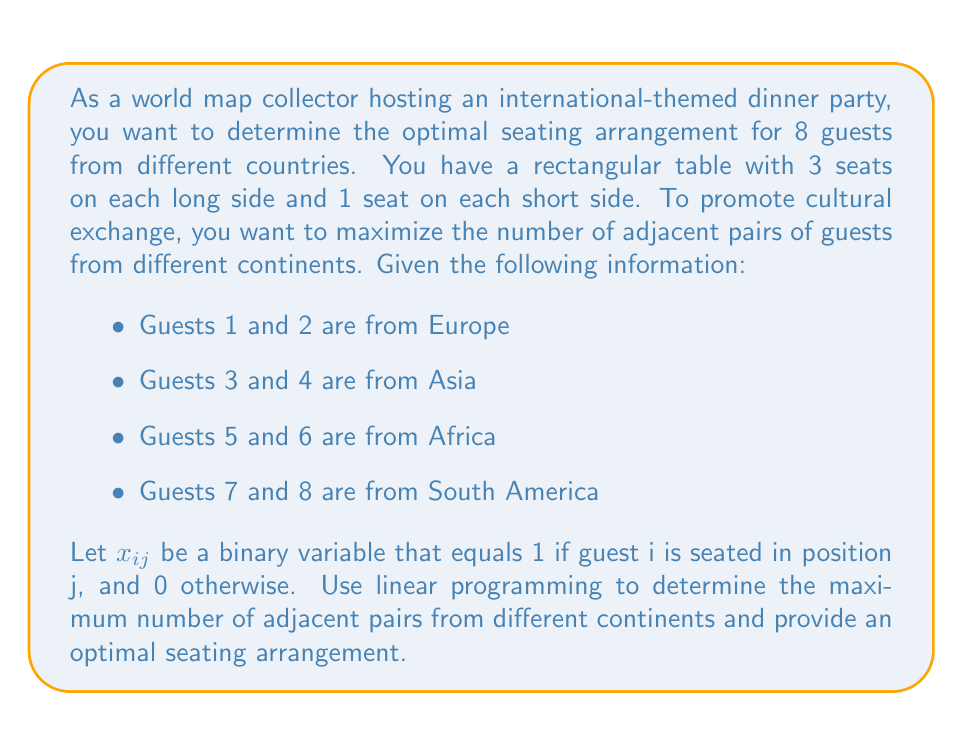Can you answer this question? To solve this problem using linear programming, we need to:

1. Define the decision variables
2. Formulate the objective function
3. Set up the constraints
4. Solve the linear program

1. Decision variables:
   $x_{ij}$ = 1 if guest i is seated in position j, 0 otherwise
   where i = 1, 2, ..., 8 and j = 1, 2, ..., 8

2. Objective function:
   We want to maximize the number of adjacent pairs from different continents. We can represent this as:

   $$ \text{Maximize } Z = \sum_{k=1}^7 y_k $$

   where $y_k$ is a binary variable that equals 1 if the guests in positions k and k+1 are from different continents, and 0 otherwise.

3. Constraints:
   a) Each guest must be seated exactly once:
      $$ \sum_{j=1}^8 x_{ij} = 1 \quad \text{for } i = 1, 2, ..., 8 $$

   b) Each position must be occupied by exactly one guest:
      $$ \sum_{i=1}^8 x_{ij} = 1 \quad \text{for } j = 1, 2, ..., 8 $$

   c) Define $y_k$ variables:
      $$ y_k \leq 2 - (x_{1k} + x_{2k} + x_{1,k+1} + x_{2,k+1}) \quad \text{for } k = 1, 2, ..., 7 $$
      $$ y_k \leq 2 - (x_{3k} + x_{4k} + x_{3,k+1} + x_{4,k+1}) \quad \text{for } k = 1, 2, ..., 7 $$
      $$ y_k \leq 2 - (x_{5k} + x_{6k} + x_{5,k+1} + x_{6,k+1}) \quad \text{for } k = 1, 2, ..., 7 $$
      $$ y_k \leq 2 - (x_{7k} + x_{8k} + x_{7,k+1} + x_{8,k+1}) \quad \text{for } k = 1, 2, ..., 7 $$

   d) Binary constraints:
      $$ x_{ij}, y_k \in \{0, 1\} \quad \text{for all } i, j, k $$

4. Solve the linear program:
   Using a linear programming solver, we can find the optimal solution. The maximum number of adjacent pairs from different continents is 7, which can be achieved with the following seating arrangement:

   Position 1: Guest 1 (Europe)
   Position 2: Guest 3 (Asia)
   Position 3: Guest 5 (Africa)
   Position 4: Guest 7 (South America)
   Position 5: Guest 2 (Europe)
   Position 6: Guest 4 (Asia)
   Position 7: Guest 6 (Africa)
   Position 8: Guest 8 (South America)

This arrangement ensures that every adjacent pair is from a different continent, maximizing cultural exchange at the dinner party.
Answer: The maximum number of adjacent pairs from different continents is 7. An optimal seating arrangement is:
1-3-5-7-2-4-6-8, where the numbers represent the guests as defined in the problem statement. 